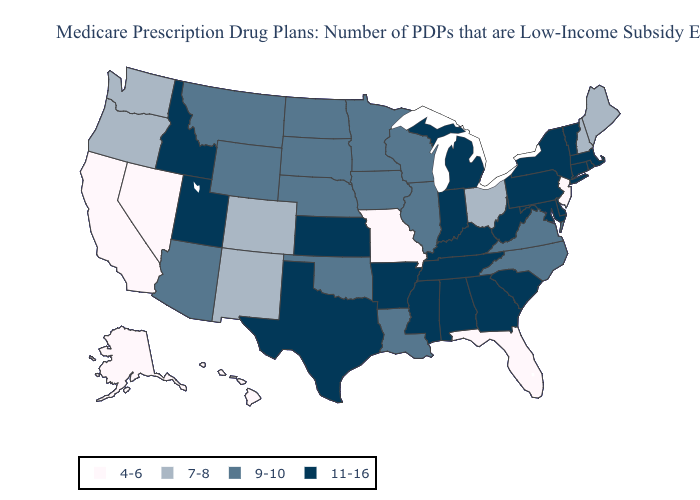What is the value of Arkansas?
Answer briefly. 11-16. What is the value of Arizona?
Short answer required. 9-10. Among the states that border Missouri , does Kentucky have the highest value?
Keep it brief. Yes. Which states hav the highest value in the MidWest?
Concise answer only. Indiana, Kansas, Michigan. Name the states that have a value in the range 4-6?
Short answer required. Alaska, California, Florida, Hawaii, Missouri, New Jersey, Nevada. Which states have the lowest value in the South?
Write a very short answer. Florida. What is the lowest value in the USA?
Concise answer only. 4-6. What is the value of Maine?
Concise answer only. 7-8. How many symbols are there in the legend?
Keep it brief. 4. What is the value of Washington?
Be succinct. 7-8. Name the states that have a value in the range 7-8?
Write a very short answer. Colorado, Maine, New Hampshire, New Mexico, Ohio, Oregon, Washington. Does the map have missing data?
Give a very brief answer. No. Name the states that have a value in the range 9-10?
Write a very short answer. Arizona, Iowa, Illinois, Louisiana, Minnesota, Montana, North Carolina, North Dakota, Nebraska, Oklahoma, South Dakota, Virginia, Wisconsin, Wyoming. What is the value of West Virginia?
Concise answer only. 11-16. Name the states that have a value in the range 11-16?
Write a very short answer. Alabama, Arkansas, Connecticut, Delaware, Georgia, Idaho, Indiana, Kansas, Kentucky, Massachusetts, Maryland, Michigan, Mississippi, New York, Pennsylvania, Rhode Island, South Carolina, Tennessee, Texas, Utah, Vermont, West Virginia. 